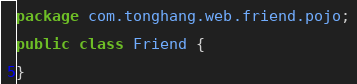Convert code to text. <code><loc_0><loc_0><loc_500><loc_500><_Java_>package com.tonghang.web.friend.pojo;

public class Friend {

}
</code> 